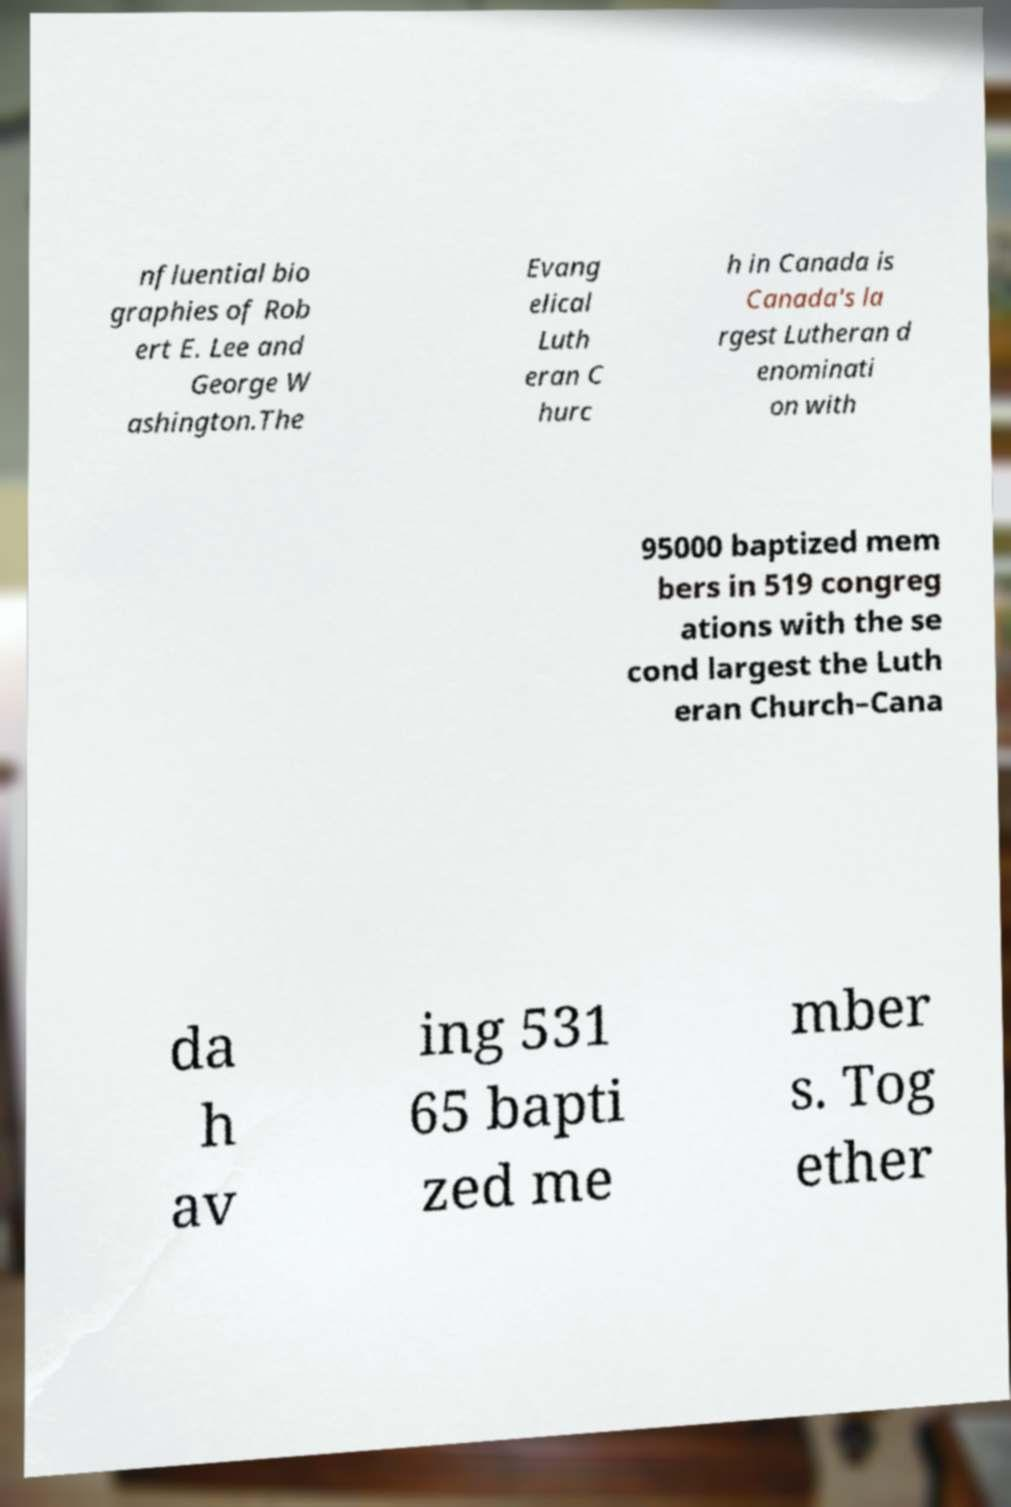Please identify and transcribe the text found in this image. nfluential bio graphies of Rob ert E. Lee and George W ashington.The Evang elical Luth eran C hurc h in Canada is Canada's la rgest Lutheran d enominati on with 95000 baptized mem bers in 519 congreg ations with the se cond largest the Luth eran Church–Cana da h av ing 531 65 bapti zed me mber s. Tog ether 